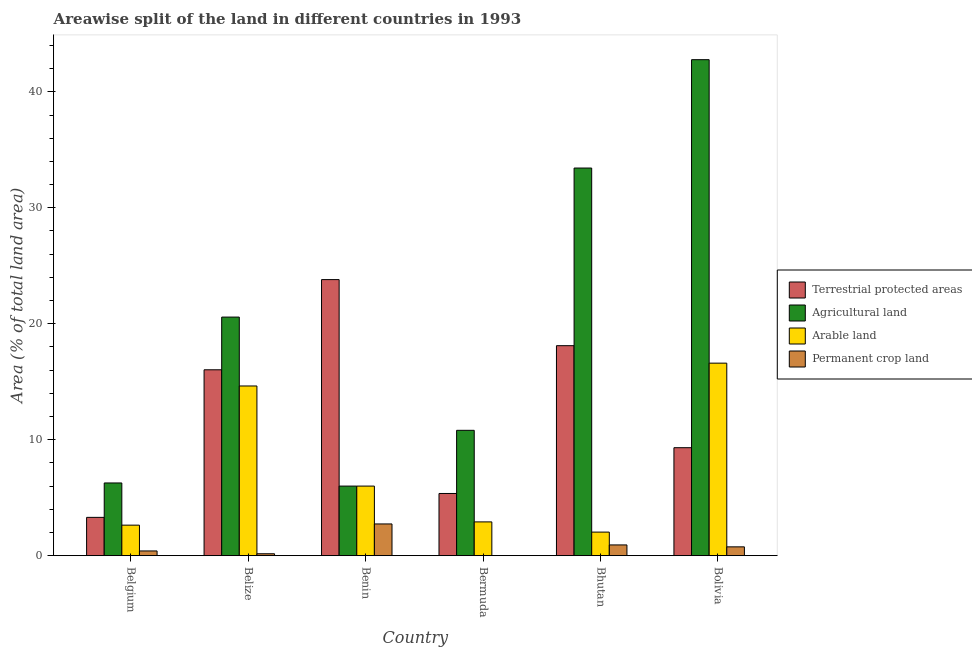Are the number of bars per tick equal to the number of legend labels?
Offer a very short reply. Yes. How many bars are there on the 3rd tick from the left?
Keep it short and to the point. 4. What is the label of the 2nd group of bars from the left?
Provide a succinct answer. Belize. In how many cases, is the number of bars for a given country not equal to the number of legend labels?
Offer a very short reply. 0. What is the percentage of land under terrestrial protection in Bhutan?
Offer a very short reply. 18.11. Across all countries, what is the maximum percentage of area under arable land?
Offer a terse response. 16.6. Across all countries, what is the minimum percentage of land under terrestrial protection?
Your answer should be compact. 3.3. In which country was the percentage of land under terrestrial protection maximum?
Your answer should be compact. Benin. In which country was the percentage of area under arable land minimum?
Your response must be concise. Bhutan. What is the total percentage of area under permanent crop land in the graph?
Offer a very short reply. 4.99. What is the difference between the percentage of area under arable land in Bhutan and that in Bolivia?
Provide a succinct answer. -14.57. What is the difference between the percentage of area under agricultural land in Benin and the percentage of area under permanent crop land in Belize?
Make the answer very short. 5.84. What is the average percentage of area under agricultural land per country?
Your answer should be compact. 19.98. What is the difference between the percentage of area under permanent crop land and percentage of area under arable land in Bermuda?
Your answer should be compact. -2.91. What is the ratio of the percentage of land under terrestrial protection in Belize to that in Benin?
Provide a short and direct response. 0.67. Is the difference between the percentage of land under terrestrial protection in Belize and Bolivia greater than the difference between the percentage of area under permanent crop land in Belize and Bolivia?
Ensure brevity in your answer.  Yes. What is the difference between the highest and the second highest percentage of area under agricultural land?
Your answer should be very brief. 9.35. What is the difference between the highest and the lowest percentage of area under arable land?
Keep it short and to the point. 14.57. In how many countries, is the percentage of area under permanent crop land greater than the average percentage of area under permanent crop land taken over all countries?
Your answer should be very brief. 2. Is it the case that in every country, the sum of the percentage of area under permanent crop land and percentage of area under arable land is greater than the sum of percentage of area under agricultural land and percentage of land under terrestrial protection?
Your answer should be compact. Yes. What does the 4th bar from the left in Belize represents?
Give a very brief answer. Permanent crop land. What does the 4th bar from the right in Bhutan represents?
Provide a succinct answer. Terrestrial protected areas. Are all the bars in the graph horizontal?
Your answer should be very brief. No. How many countries are there in the graph?
Provide a short and direct response. 6. Are the values on the major ticks of Y-axis written in scientific E-notation?
Offer a very short reply. No. Does the graph contain any zero values?
Make the answer very short. No. Does the graph contain grids?
Ensure brevity in your answer.  No. How many legend labels are there?
Provide a succinct answer. 4. What is the title of the graph?
Your answer should be very brief. Areawise split of the land in different countries in 1993. Does "PFC gas" appear as one of the legend labels in the graph?
Offer a very short reply. No. What is the label or title of the X-axis?
Offer a terse response. Country. What is the label or title of the Y-axis?
Your response must be concise. Area (% of total land area). What is the Area (% of total land area) in Terrestrial protected areas in Belgium?
Keep it short and to the point. 3.3. What is the Area (% of total land area) in Agricultural land in Belgium?
Your answer should be very brief. 6.27. What is the Area (% of total land area) in Arable land in Belgium?
Your answer should be very brief. 2.63. What is the Area (% of total land area) in Permanent crop land in Belgium?
Ensure brevity in your answer.  0.41. What is the Area (% of total land area) of Terrestrial protected areas in Belize?
Offer a very short reply. 16.03. What is the Area (% of total land area) of Agricultural land in Belize?
Your answer should be very brief. 20.57. What is the Area (% of total land area) of Arable land in Belize?
Offer a terse response. 14.63. What is the Area (% of total land area) of Permanent crop land in Belize?
Ensure brevity in your answer.  0.16. What is the Area (% of total land area) of Terrestrial protected areas in Benin?
Your response must be concise. 23.81. What is the Area (% of total land area) of Agricultural land in Benin?
Your answer should be compact. 6. What is the Area (% of total land area) of Arable land in Benin?
Provide a succinct answer. 6. What is the Area (% of total land area) of Permanent crop land in Benin?
Offer a terse response. 2.73. What is the Area (% of total land area) of Terrestrial protected areas in Bermuda?
Keep it short and to the point. 5.36. What is the Area (% of total land area) of Agricultural land in Bermuda?
Your answer should be very brief. 10.81. What is the Area (% of total land area) of Arable land in Bermuda?
Your response must be concise. 2.91. What is the Area (% of total land area) in Permanent crop land in Bermuda?
Offer a terse response. 0. What is the Area (% of total land area) in Terrestrial protected areas in Bhutan?
Offer a terse response. 18.11. What is the Area (% of total land area) in Agricultural land in Bhutan?
Give a very brief answer. 33.43. What is the Area (% of total land area) of Arable land in Bhutan?
Your response must be concise. 2.03. What is the Area (% of total land area) of Permanent crop land in Bhutan?
Provide a succinct answer. 0.93. What is the Area (% of total land area) of Terrestrial protected areas in Bolivia?
Ensure brevity in your answer.  9.31. What is the Area (% of total land area) of Agricultural land in Bolivia?
Provide a succinct answer. 42.77. What is the Area (% of total land area) in Arable land in Bolivia?
Offer a terse response. 16.6. What is the Area (% of total land area) in Permanent crop land in Bolivia?
Provide a short and direct response. 0.76. Across all countries, what is the maximum Area (% of total land area) of Terrestrial protected areas?
Your answer should be very brief. 23.81. Across all countries, what is the maximum Area (% of total land area) of Agricultural land?
Provide a short and direct response. 42.77. Across all countries, what is the maximum Area (% of total land area) in Arable land?
Your answer should be very brief. 16.6. Across all countries, what is the maximum Area (% of total land area) in Permanent crop land?
Offer a terse response. 2.73. Across all countries, what is the minimum Area (% of total land area) of Terrestrial protected areas?
Your answer should be compact. 3.3. Across all countries, what is the minimum Area (% of total land area) in Agricultural land?
Your answer should be compact. 6. Across all countries, what is the minimum Area (% of total land area) in Arable land?
Provide a succinct answer. 2.03. Across all countries, what is the minimum Area (% of total land area) in Permanent crop land?
Provide a short and direct response. 0. What is the total Area (% of total land area) of Terrestrial protected areas in the graph?
Your answer should be compact. 75.92. What is the total Area (% of total land area) of Agricultural land in the graph?
Offer a very short reply. 119.85. What is the total Area (% of total land area) of Arable land in the graph?
Offer a very short reply. 44.81. What is the total Area (% of total land area) of Permanent crop land in the graph?
Your response must be concise. 4.99. What is the difference between the Area (% of total land area) in Terrestrial protected areas in Belgium and that in Belize?
Offer a terse response. -12.73. What is the difference between the Area (% of total land area) of Agricultural land in Belgium and that in Belize?
Provide a short and direct response. -14.31. What is the difference between the Area (% of total land area) of Arable land in Belgium and that in Belize?
Offer a terse response. -12. What is the difference between the Area (% of total land area) in Permanent crop land in Belgium and that in Belize?
Provide a succinct answer. 0.24. What is the difference between the Area (% of total land area) in Terrestrial protected areas in Belgium and that in Benin?
Keep it short and to the point. -20.51. What is the difference between the Area (% of total land area) of Agricultural land in Belgium and that in Benin?
Ensure brevity in your answer.  0.27. What is the difference between the Area (% of total land area) of Arable land in Belgium and that in Benin?
Offer a very short reply. -3.37. What is the difference between the Area (% of total land area) in Permanent crop land in Belgium and that in Benin?
Provide a succinct answer. -2.33. What is the difference between the Area (% of total land area) in Terrestrial protected areas in Belgium and that in Bermuda?
Provide a succinct answer. -2.06. What is the difference between the Area (% of total land area) of Agricultural land in Belgium and that in Bermuda?
Give a very brief answer. -4.54. What is the difference between the Area (% of total land area) in Arable land in Belgium and that in Bermuda?
Provide a short and direct response. -0.28. What is the difference between the Area (% of total land area) in Permanent crop land in Belgium and that in Bermuda?
Offer a terse response. 0.4. What is the difference between the Area (% of total land area) in Terrestrial protected areas in Belgium and that in Bhutan?
Provide a succinct answer. -14.81. What is the difference between the Area (% of total land area) of Agricultural land in Belgium and that in Bhutan?
Offer a very short reply. -27.16. What is the difference between the Area (% of total land area) in Arable land in Belgium and that in Bhutan?
Provide a short and direct response. 0.6. What is the difference between the Area (% of total land area) of Permanent crop land in Belgium and that in Bhutan?
Provide a succinct answer. -0.52. What is the difference between the Area (% of total land area) of Terrestrial protected areas in Belgium and that in Bolivia?
Your answer should be very brief. -6.01. What is the difference between the Area (% of total land area) of Agricultural land in Belgium and that in Bolivia?
Make the answer very short. -36.5. What is the difference between the Area (% of total land area) of Arable land in Belgium and that in Bolivia?
Give a very brief answer. -13.97. What is the difference between the Area (% of total land area) in Permanent crop land in Belgium and that in Bolivia?
Provide a short and direct response. -0.35. What is the difference between the Area (% of total land area) of Terrestrial protected areas in Belize and that in Benin?
Offer a very short reply. -7.78. What is the difference between the Area (% of total land area) in Agricultural land in Belize and that in Benin?
Provide a short and direct response. 14.57. What is the difference between the Area (% of total land area) of Arable land in Belize and that in Benin?
Offer a very short reply. 8.63. What is the difference between the Area (% of total land area) in Permanent crop land in Belize and that in Benin?
Your answer should be compact. -2.57. What is the difference between the Area (% of total land area) of Terrestrial protected areas in Belize and that in Bermuda?
Your answer should be very brief. 10.67. What is the difference between the Area (% of total land area) in Agricultural land in Belize and that in Bermuda?
Make the answer very short. 9.77. What is the difference between the Area (% of total land area) in Arable land in Belize and that in Bermuda?
Your answer should be compact. 11.72. What is the difference between the Area (% of total land area) in Permanent crop land in Belize and that in Bermuda?
Keep it short and to the point. 0.16. What is the difference between the Area (% of total land area) of Terrestrial protected areas in Belize and that in Bhutan?
Make the answer very short. -2.08. What is the difference between the Area (% of total land area) in Agricultural land in Belize and that in Bhutan?
Ensure brevity in your answer.  -12.85. What is the difference between the Area (% of total land area) of Arable land in Belize and that in Bhutan?
Ensure brevity in your answer.  12.6. What is the difference between the Area (% of total land area) of Permanent crop land in Belize and that in Bhutan?
Give a very brief answer. -0.76. What is the difference between the Area (% of total land area) of Terrestrial protected areas in Belize and that in Bolivia?
Your response must be concise. 6.72. What is the difference between the Area (% of total land area) of Agricultural land in Belize and that in Bolivia?
Provide a short and direct response. -22.2. What is the difference between the Area (% of total land area) of Arable land in Belize and that in Bolivia?
Offer a very short reply. -1.97. What is the difference between the Area (% of total land area) in Permanent crop land in Belize and that in Bolivia?
Provide a succinct answer. -0.59. What is the difference between the Area (% of total land area) in Terrestrial protected areas in Benin and that in Bermuda?
Your answer should be compact. 18.45. What is the difference between the Area (% of total land area) in Agricultural land in Benin and that in Bermuda?
Ensure brevity in your answer.  -4.81. What is the difference between the Area (% of total land area) of Arable land in Benin and that in Bermuda?
Provide a short and direct response. 3.09. What is the difference between the Area (% of total land area) of Permanent crop land in Benin and that in Bermuda?
Your response must be concise. 2.73. What is the difference between the Area (% of total land area) in Terrestrial protected areas in Benin and that in Bhutan?
Make the answer very short. 5.7. What is the difference between the Area (% of total land area) of Agricultural land in Benin and that in Bhutan?
Provide a succinct answer. -27.43. What is the difference between the Area (% of total land area) in Arable land in Benin and that in Bhutan?
Offer a terse response. 3.97. What is the difference between the Area (% of total land area) in Permanent crop land in Benin and that in Bhutan?
Offer a terse response. 1.81. What is the difference between the Area (% of total land area) in Terrestrial protected areas in Benin and that in Bolivia?
Provide a short and direct response. 14.5. What is the difference between the Area (% of total land area) in Agricultural land in Benin and that in Bolivia?
Your response must be concise. -36.77. What is the difference between the Area (% of total land area) in Arable land in Benin and that in Bolivia?
Offer a terse response. -10.6. What is the difference between the Area (% of total land area) of Permanent crop land in Benin and that in Bolivia?
Offer a very short reply. 1.98. What is the difference between the Area (% of total land area) of Terrestrial protected areas in Bermuda and that in Bhutan?
Your answer should be compact. -12.75. What is the difference between the Area (% of total land area) of Agricultural land in Bermuda and that in Bhutan?
Your response must be concise. -22.62. What is the difference between the Area (% of total land area) in Arable land in Bermuda and that in Bhutan?
Provide a short and direct response. 0.88. What is the difference between the Area (% of total land area) of Permanent crop land in Bermuda and that in Bhutan?
Keep it short and to the point. -0.92. What is the difference between the Area (% of total land area) in Terrestrial protected areas in Bermuda and that in Bolivia?
Provide a short and direct response. -3.95. What is the difference between the Area (% of total land area) of Agricultural land in Bermuda and that in Bolivia?
Ensure brevity in your answer.  -31.97. What is the difference between the Area (% of total land area) in Arable land in Bermuda and that in Bolivia?
Offer a terse response. -13.69. What is the difference between the Area (% of total land area) in Permanent crop land in Bermuda and that in Bolivia?
Provide a succinct answer. -0.76. What is the difference between the Area (% of total land area) in Terrestrial protected areas in Bhutan and that in Bolivia?
Give a very brief answer. 8.8. What is the difference between the Area (% of total land area) of Agricultural land in Bhutan and that in Bolivia?
Your response must be concise. -9.35. What is the difference between the Area (% of total land area) in Arable land in Bhutan and that in Bolivia?
Offer a very short reply. -14.57. What is the difference between the Area (% of total land area) in Permanent crop land in Bhutan and that in Bolivia?
Offer a terse response. 0.17. What is the difference between the Area (% of total land area) in Terrestrial protected areas in Belgium and the Area (% of total land area) in Agricultural land in Belize?
Your response must be concise. -17.27. What is the difference between the Area (% of total land area) of Terrestrial protected areas in Belgium and the Area (% of total land area) of Arable land in Belize?
Ensure brevity in your answer.  -11.33. What is the difference between the Area (% of total land area) in Terrestrial protected areas in Belgium and the Area (% of total land area) in Permanent crop land in Belize?
Your response must be concise. 3.14. What is the difference between the Area (% of total land area) in Agricultural land in Belgium and the Area (% of total land area) in Arable land in Belize?
Give a very brief answer. -8.36. What is the difference between the Area (% of total land area) of Agricultural land in Belgium and the Area (% of total land area) of Permanent crop land in Belize?
Give a very brief answer. 6.1. What is the difference between the Area (% of total land area) in Arable land in Belgium and the Area (% of total land area) in Permanent crop land in Belize?
Ensure brevity in your answer.  2.47. What is the difference between the Area (% of total land area) in Terrestrial protected areas in Belgium and the Area (% of total land area) in Agricultural land in Benin?
Offer a terse response. -2.7. What is the difference between the Area (% of total land area) in Terrestrial protected areas in Belgium and the Area (% of total land area) in Arable land in Benin?
Make the answer very short. -2.7. What is the difference between the Area (% of total land area) of Terrestrial protected areas in Belgium and the Area (% of total land area) of Permanent crop land in Benin?
Offer a very short reply. 0.57. What is the difference between the Area (% of total land area) in Agricultural land in Belgium and the Area (% of total land area) in Arable land in Benin?
Provide a short and direct response. 0.27. What is the difference between the Area (% of total land area) in Agricultural land in Belgium and the Area (% of total land area) in Permanent crop land in Benin?
Offer a terse response. 3.53. What is the difference between the Area (% of total land area) of Arable land in Belgium and the Area (% of total land area) of Permanent crop land in Benin?
Your response must be concise. -0.1. What is the difference between the Area (% of total land area) in Terrestrial protected areas in Belgium and the Area (% of total land area) in Agricultural land in Bermuda?
Your answer should be compact. -7.51. What is the difference between the Area (% of total land area) in Terrestrial protected areas in Belgium and the Area (% of total land area) in Arable land in Bermuda?
Make the answer very short. 0.39. What is the difference between the Area (% of total land area) in Terrestrial protected areas in Belgium and the Area (% of total land area) in Permanent crop land in Bermuda?
Give a very brief answer. 3.3. What is the difference between the Area (% of total land area) of Agricultural land in Belgium and the Area (% of total land area) of Arable land in Bermuda?
Offer a terse response. 3.36. What is the difference between the Area (% of total land area) of Agricultural land in Belgium and the Area (% of total land area) of Permanent crop land in Bermuda?
Your answer should be compact. 6.27. What is the difference between the Area (% of total land area) of Arable land in Belgium and the Area (% of total land area) of Permanent crop land in Bermuda?
Keep it short and to the point. 2.63. What is the difference between the Area (% of total land area) in Terrestrial protected areas in Belgium and the Area (% of total land area) in Agricultural land in Bhutan?
Your response must be concise. -30.13. What is the difference between the Area (% of total land area) of Terrestrial protected areas in Belgium and the Area (% of total land area) of Arable land in Bhutan?
Your answer should be compact. 1.27. What is the difference between the Area (% of total land area) in Terrestrial protected areas in Belgium and the Area (% of total land area) in Permanent crop land in Bhutan?
Your answer should be compact. 2.38. What is the difference between the Area (% of total land area) in Agricultural land in Belgium and the Area (% of total land area) in Arable land in Bhutan?
Provide a succinct answer. 4.24. What is the difference between the Area (% of total land area) of Agricultural land in Belgium and the Area (% of total land area) of Permanent crop land in Bhutan?
Make the answer very short. 5.34. What is the difference between the Area (% of total land area) in Arable land in Belgium and the Area (% of total land area) in Permanent crop land in Bhutan?
Give a very brief answer. 1.7. What is the difference between the Area (% of total land area) of Terrestrial protected areas in Belgium and the Area (% of total land area) of Agricultural land in Bolivia?
Ensure brevity in your answer.  -39.47. What is the difference between the Area (% of total land area) of Terrestrial protected areas in Belgium and the Area (% of total land area) of Arable land in Bolivia?
Offer a terse response. -13.3. What is the difference between the Area (% of total land area) in Terrestrial protected areas in Belgium and the Area (% of total land area) in Permanent crop land in Bolivia?
Your answer should be compact. 2.54. What is the difference between the Area (% of total land area) in Agricultural land in Belgium and the Area (% of total land area) in Arable land in Bolivia?
Your answer should be very brief. -10.33. What is the difference between the Area (% of total land area) in Agricultural land in Belgium and the Area (% of total land area) in Permanent crop land in Bolivia?
Your answer should be very brief. 5.51. What is the difference between the Area (% of total land area) in Arable land in Belgium and the Area (% of total land area) in Permanent crop land in Bolivia?
Your answer should be compact. 1.87. What is the difference between the Area (% of total land area) of Terrestrial protected areas in Belize and the Area (% of total land area) of Agricultural land in Benin?
Provide a succinct answer. 10.03. What is the difference between the Area (% of total land area) of Terrestrial protected areas in Belize and the Area (% of total land area) of Arable land in Benin?
Offer a terse response. 10.03. What is the difference between the Area (% of total land area) of Terrestrial protected areas in Belize and the Area (% of total land area) of Permanent crop land in Benin?
Offer a terse response. 13.3. What is the difference between the Area (% of total land area) of Agricultural land in Belize and the Area (% of total land area) of Arable land in Benin?
Your response must be concise. 14.57. What is the difference between the Area (% of total land area) of Agricultural land in Belize and the Area (% of total land area) of Permanent crop land in Benin?
Provide a short and direct response. 17.84. What is the difference between the Area (% of total land area) in Arable land in Belize and the Area (% of total land area) in Permanent crop land in Benin?
Your answer should be very brief. 11.9. What is the difference between the Area (% of total land area) in Terrestrial protected areas in Belize and the Area (% of total land area) in Agricultural land in Bermuda?
Make the answer very short. 5.22. What is the difference between the Area (% of total land area) in Terrestrial protected areas in Belize and the Area (% of total land area) in Arable land in Bermuda?
Give a very brief answer. 13.12. What is the difference between the Area (% of total land area) in Terrestrial protected areas in Belize and the Area (% of total land area) in Permanent crop land in Bermuda?
Provide a succinct answer. 16.03. What is the difference between the Area (% of total land area) of Agricultural land in Belize and the Area (% of total land area) of Arable land in Bermuda?
Offer a terse response. 17.66. What is the difference between the Area (% of total land area) of Agricultural land in Belize and the Area (% of total land area) of Permanent crop land in Bermuda?
Your answer should be compact. 20.57. What is the difference between the Area (% of total land area) of Arable land in Belize and the Area (% of total land area) of Permanent crop land in Bermuda?
Give a very brief answer. 14.63. What is the difference between the Area (% of total land area) in Terrestrial protected areas in Belize and the Area (% of total land area) in Agricultural land in Bhutan?
Offer a very short reply. -17.4. What is the difference between the Area (% of total land area) of Terrestrial protected areas in Belize and the Area (% of total land area) of Arable land in Bhutan?
Your answer should be compact. 14. What is the difference between the Area (% of total land area) of Terrestrial protected areas in Belize and the Area (% of total land area) of Permanent crop land in Bhutan?
Offer a terse response. 15.1. What is the difference between the Area (% of total land area) in Agricultural land in Belize and the Area (% of total land area) in Arable land in Bhutan?
Ensure brevity in your answer.  18.54. What is the difference between the Area (% of total land area) of Agricultural land in Belize and the Area (% of total land area) of Permanent crop land in Bhutan?
Your response must be concise. 19.65. What is the difference between the Area (% of total land area) of Arable land in Belize and the Area (% of total land area) of Permanent crop land in Bhutan?
Give a very brief answer. 13.71. What is the difference between the Area (% of total land area) in Terrestrial protected areas in Belize and the Area (% of total land area) in Agricultural land in Bolivia?
Offer a terse response. -26.74. What is the difference between the Area (% of total land area) of Terrestrial protected areas in Belize and the Area (% of total land area) of Arable land in Bolivia?
Your response must be concise. -0.57. What is the difference between the Area (% of total land area) in Terrestrial protected areas in Belize and the Area (% of total land area) in Permanent crop land in Bolivia?
Offer a very short reply. 15.27. What is the difference between the Area (% of total land area) of Agricultural land in Belize and the Area (% of total land area) of Arable land in Bolivia?
Provide a short and direct response. 3.97. What is the difference between the Area (% of total land area) of Agricultural land in Belize and the Area (% of total land area) of Permanent crop land in Bolivia?
Make the answer very short. 19.82. What is the difference between the Area (% of total land area) in Arable land in Belize and the Area (% of total land area) in Permanent crop land in Bolivia?
Make the answer very short. 13.87. What is the difference between the Area (% of total land area) in Terrestrial protected areas in Benin and the Area (% of total land area) in Agricultural land in Bermuda?
Ensure brevity in your answer.  13. What is the difference between the Area (% of total land area) in Terrestrial protected areas in Benin and the Area (% of total land area) in Arable land in Bermuda?
Offer a terse response. 20.9. What is the difference between the Area (% of total land area) in Terrestrial protected areas in Benin and the Area (% of total land area) in Permanent crop land in Bermuda?
Provide a short and direct response. 23.81. What is the difference between the Area (% of total land area) in Agricultural land in Benin and the Area (% of total land area) in Arable land in Bermuda?
Your answer should be very brief. 3.09. What is the difference between the Area (% of total land area) of Agricultural land in Benin and the Area (% of total land area) of Permanent crop land in Bermuda?
Keep it short and to the point. 6. What is the difference between the Area (% of total land area) in Arable land in Benin and the Area (% of total land area) in Permanent crop land in Bermuda?
Give a very brief answer. 6. What is the difference between the Area (% of total land area) in Terrestrial protected areas in Benin and the Area (% of total land area) in Agricultural land in Bhutan?
Your response must be concise. -9.62. What is the difference between the Area (% of total land area) in Terrestrial protected areas in Benin and the Area (% of total land area) in Arable land in Bhutan?
Give a very brief answer. 21.78. What is the difference between the Area (% of total land area) of Terrestrial protected areas in Benin and the Area (% of total land area) of Permanent crop land in Bhutan?
Your answer should be very brief. 22.88. What is the difference between the Area (% of total land area) in Agricultural land in Benin and the Area (% of total land area) in Arable land in Bhutan?
Your answer should be very brief. 3.97. What is the difference between the Area (% of total land area) of Agricultural land in Benin and the Area (% of total land area) of Permanent crop land in Bhutan?
Your answer should be compact. 5.07. What is the difference between the Area (% of total land area) of Arable land in Benin and the Area (% of total land area) of Permanent crop land in Bhutan?
Your response must be concise. 5.07. What is the difference between the Area (% of total land area) of Terrestrial protected areas in Benin and the Area (% of total land area) of Agricultural land in Bolivia?
Provide a succinct answer. -18.97. What is the difference between the Area (% of total land area) in Terrestrial protected areas in Benin and the Area (% of total land area) in Arable land in Bolivia?
Make the answer very short. 7.21. What is the difference between the Area (% of total land area) in Terrestrial protected areas in Benin and the Area (% of total land area) in Permanent crop land in Bolivia?
Offer a very short reply. 23.05. What is the difference between the Area (% of total land area) of Agricultural land in Benin and the Area (% of total land area) of Arable land in Bolivia?
Provide a succinct answer. -10.6. What is the difference between the Area (% of total land area) in Agricultural land in Benin and the Area (% of total land area) in Permanent crop land in Bolivia?
Give a very brief answer. 5.24. What is the difference between the Area (% of total land area) of Arable land in Benin and the Area (% of total land area) of Permanent crop land in Bolivia?
Ensure brevity in your answer.  5.24. What is the difference between the Area (% of total land area) of Terrestrial protected areas in Bermuda and the Area (% of total land area) of Agricultural land in Bhutan?
Provide a short and direct response. -28.07. What is the difference between the Area (% of total land area) of Terrestrial protected areas in Bermuda and the Area (% of total land area) of Arable land in Bhutan?
Your answer should be very brief. 3.33. What is the difference between the Area (% of total land area) in Terrestrial protected areas in Bermuda and the Area (% of total land area) in Permanent crop land in Bhutan?
Keep it short and to the point. 4.44. What is the difference between the Area (% of total land area) in Agricultural land in Bermuda and the Area (% of total land area) in Arable land in Bhutan?
Give a very brief answer. 8.78. What is the difference between the Area (% of total land area) in Agricultural land in Bermuda and the Area (% of total land area) in Permanent crop land in Bhutan?
Give a very brief answer. 9.88. What is the difference between the Area (% of total land area) in Arable land in Bermuda and the Area (% of total land area) in Permanent crop land in Bhutan?
Give a very brief answer. 1.99. What is the difference between the Area (% of total land area) of Terrestrial protected areas in Bermuda and the Area (% of total land area) of Agricultural land in Bolivia?
Offer a very short reply. -37.41. What is the difference between the Area (% of total land area) of Terrestrial protected areas in Bermuda and the Area (% of total land area) of Arable land in Bolivia?
Make the answer very short. -11.24. What is the difference between the Area (% of total land area) in Terrestrial protected areas in Bermuda and the Area (% of total land area) in Permanent crop land in Bolivia?
Ensure brevity in your answer.  4.6. What is the difference between the Area (% of total land area) in Agricultural land in Bermuda and the Area (% of total land area) in Arable land in Bolivia?
Give a very brief answer. -5.79. What is the difference between the Area (% of total land area) of Agricultural land in Bermuda and the Area (% of total land area) of Permanent crop land in Bolivia?
Your answer should be very brief. 10.05. What is the difference between the Area (% of total land area) in Arable land in Bermuda and the Area (% of total land area) in Permanent crop land in Bolivia?
Your response must be concise. 2.15. What is the difference between the Area (% of total land area) in Terrestrial protected areas in Bhutan and the Area (% of total land area) in Agricultural land in Bolivia?
Provide a short and direct response. -24.66. What is the difference between the Area (% of total land area) of Terrestrial protected areas in Bhutan and the Area (% of total land area) of Arable land in Bolivia?
Offer a terse response. 1.51. What is the difference between the Area (% of total land area) of Terrestrial protected areas in Bhutan and the Area (% of total land area) of Permanent crop land in Bolivia?
Your response must be concise. 17.35. What is the difference between the Area (% of total land area) in Agricultural land in Bhutan and the Area (% of total land area) in Arable land in Bolivia?
Keep it short and to the point. 16.83. What is the difference between the Area (% of total land area) of Agricultural land in Bhutan and the Area (% of total land area) of Permanent crop land in Bolivia?
Offer a terse response. 32.67. What is the difference between the Area (% of total land area) of Arable land in Bhutan and the Area (% of total land area) of Permanent crop land in Bolivia?
Your response must be concise. 1.27. What is the average Area (% of total land area) in Terrestrial protected areas per country?
Make the answer very short. 12.65. What is the average Area (% of total land area) of Agricultural land per country?
Your response must be concise. 19.98. What is the average Area (% of total land area) in Arable land per country?
Keep it short and to the point. 7.47. What is the average Area (% of total land area) of Permanent crop land per country?
Offer a very short reply. 0.83. What is the difference between the Area (% of total land area) in Terrestrial protected areas and Area (% of total land area) in Agricultural land in Belgium?
Your answer should be compact. -2.97. What is the difference between the Area (% of total land area) in Terrestrial protected areas and Area (% of total land area) in Arable land in Belgium?
Keep it short and to the point. 0.67. What is the difference between the Area (% of total land area) in Terrestrial protected areas and Area (% of total land area) in Permanent crop land in Belgium?
Give a very brief answer. 2.89. What is the difference between the Area (% of total land area) in Agricultural land and Area (% of total land area) in Arable land in Belgium?
Make the answer very short. 3.64. What is the difference between the Area (% of total land area) in Agricultural land and Area (% of total land area) in Permanent crop land in Belgium?
Offer a terse response. 5.86. What is the difference between the Area (% of total land area) in Arable land and Area (% of total land area) in Permanent crop land in Belgium?
Your answer should be very brief. 2.22. What is the difference between the Area (% of total land area) of Terrestrial protected areas and Area (% of total land area) of Agricultural land in Belize?
Offer a very short reply. -4.55. What is the difference between the Area (% of total land area) in Terrestrial protected areas and Area (% of total land area) in Arable land in Belize?
Your answer should be compact. 1.4. What is the difference between the Area (% of total land area) of Terrestrial protected areas and Area (% of total land area) of Permanent crop land in Belize?
Offer a very short reply. 15.87. What is the difference between the Area (% of total land area) of Agricultural land and Area (% of total land area) of Arable land in Belize?
Offer a terse response. 5.94. What is the difference between the Area (% of total land area) in Agricultural land and Area (% of total land area) in Permanent crop land in Belize?
Keep it short and to the point. 20.41. What is the difference between the Area (% of total land area) of Arable land and Area (% of total land area) of Permanent crop land in Belize?
Offer a terse response. 14.47. What is the difference between the Area (% of total land area) of Terrestrial protected areas and Area (% of total land area) of Agricultural land in Benin?
Make the answer very short. 17.81. What is the difference between the Area (% of total land area) of Terrestrial protected areas and Area (% of total land area) of Arable land in Benin?
Provide a succinct answer. 17.81. What is the difference between the Area (% of total land area) of Terrestrial protected areas and Area (% of total land area) of Permanent crop land in Benin?
Keep it short and to the point. 21.07. What is the difference between the Area (% of total land area) in Agricultural land and Area (% of total land area) in Permanent crop land in Benin?
Give a very brief answer. 3.27. What is the difference between the Area (% of total land area) in Arable land and Area (% of total land area) in Permanent crop land in Benin?
Keep it short and to the point. 3.27. What is the difference between the Area (% of total land area) of Terrestrial protected areas and Area (% of total land area) of Agricultural land in Bermuda?
Your response must be concise. -5.45. What is the difference between the Area (% of total land area) in Terrestrial protected areas and Area (% of total land area) in Arable land in Bermuda?
Provide a short and direct response. 2.45. What is the difference between the Area (% of total land area) of Terrestrial protected areas and Area (% of total land area) of Permanent crop land in Bermuda?
Offer a very short reply. 5.36. What is the difference between the Area (% of total land area) of Agricultural land and Area (% of total land area) of Arable land in Bermuda?
Provide a short and direct response. 7.9. What is the difference between the Area (% of total land area) of Agricultural land and Area (% of total land area) of Permanent crop land in Bermuda?
Your answer should be compact. 10.81. What is the difference between the Area (% of total land area) of Arable land and Area (% of total land area) of Permanent crop land in Bermuda?
Make the answer very short. 2.91. What is the difference between the Area (% of total land area) of Terrestrial protected areas and Area (% of total land area) of Agricultural land in Bhutan?
Your response must be concise. -15.32. What is the difference between the Area (% of total land area) of Terrestrial protected areas and Area (% of total land area) of Arable land in Bhutan?
Ensure brevity in your answer.  16.08. What is the difference between the Area (% of total land area) of Terrestrial protected areas and Area (% of total land area) of Permanent crop land in Bhutan?
Your response must be concise. 17.18. What is the difference between the Area (% of total land area) of Agricultural land and Area (% of total land area) of Arable land in Bhutan?
Provide a short and direct response. 31.4. What is the difference between the Area (% of total land area) in Agricultural land and Area (% of total land area) in Permanent crop land in Bhutan?
Ensure brevity in your answer.  32.5. What is the difference between the Area (% of total land area) of Arable land and Area (% of total land area) of Permanent crop land in Bhutan?
Your response must be concise. 1.11. What is the difference between the Area (% of total land area) in Terrestrial protected areas and Area (% of total land area) in Agricultural land in Bolivia?
Ensure brevity in your answer.  -33.46. What is the difference between the Area (% of total land area) of Terrestrial protected areas and Area (% of total land area) of Arable land in Bolivia?
Provide a short and direct response. -7.29. What is the difference between the Area (% of total land area) in Terrestrial protected areas and Area (% of total land area) in Permanent crop land in Bolivia?
Your answer should be compact. 8.55. What is the difference between the Area (% of total land area) of Agricultural land and Area (% of total land area) of Arable land in Bolivia?
Your response must be concise. 26.17. What is the difference between the Area (% of total land area) of Agricultural land and Area (% of total land area) of Permanent crop land in Bolivia?
Your answer should be compact. 42.01. What is the difference between the Area (% of total land area) of Arable land and Area (% of total land area) of Permanent crop land in Bolivia?
Keep it short and to the point. 15.84. What is the ratio of the Area (% of total land area) of Terrestrial protected areas in Belgium to that in Belize?
Your answer should be very brief. 0.21. What is the ratio of the Area (% of total land area) in Agricultural land in Belgium to that in Belize?
Your answer should be very brief. 0.3. What is the ratio of the Area (% of total land area) in Arable land in Belgium to that in Belize?
Offer a terse response. 0.18. What is the ratio of the Area (% of total land area) of Permanent crop land in Belgium to that in Belize?
Make the answer very short. 2.47. What is the ratio of the Area (% of total land area) of Terrestrial protected areas in Belgium to that in Benin?
Keep it short and to the point. 0.14. What is the ratio of the Area (% of total land area) of Agricultural land in Belgium to that in Benin?
Your response must be concise. 1.04. What is the ratio of the Area (% of total land area) of Arable land in Belgium to that in Benin?
Provide a succinct answer. 0.44. What is the ratio of the Area (% of total land area) in Permanent crop land in Belgium to that in Benin?
Make the answer very short. 0.15. What is the ratio of the Area (% of total land area) in Terrestrial protected areas in Belgium to that in Bermuda?
Give a very brief answer. 0.62. What is the ratio of the Area (% of total land area) of Agricultural land in Belgium to that in Bermuda?
Ensure brevity in your answer.  0.58. What is the ratio of the Area (% of total land area) in Arable land in Belgium to that in Bermuda?
Offer a very short reply. 0.9. What is the ratio of the Area (% of total land area) in Permanent crop land in Belgium to that in Bermuda?
Your answer should be compact. 230.46. What is the ratio of the Area (% of total land area) in Terrestrial protected areas in Belgium to that in Bhutan?
Your response must be concise. 0.18. What is the ratio of the Area (% of total land area) of Agricultural land in Belgium to that in Bhutan?
Provide a succinct answer. 0.19. What is the ratio of the Area (% of total land area) in Arable land in Belgium to that in Bhutan?
Your response must be concise. 1.3. What is the ratio of the Area (% of total land area) of Permanent crop land in Belgium to that in Bhutan?
Provide a short and direct response. 0.44. What is the ratio of the Area (% of total land area) in Terrestrial protected areas in Belgium to that in Bolivia?
Provide a short and direct response. 0.35. What is the ratio of the Area (% of total land area) in Agricultural land in Belgium to that in Bolivia?
Your answer should be very brief. 0.15. What is the ratio of the Area (% of total land area) of Arable land in Belgium to that in Bolivia?
Keep it short and to the point. 0.16. What is the ratio of the Area (% of total land area) of Permanent crop land in Belgium to that in Bolivia?
Offer a very short reply. 0.54. What is the ratio of the Area (% of total land area) of Terrestrial protected areas in Belize to that in Benin?
Make the answer very short. 0.67. What is the ratio of the Area (% of total land area) of Agricultural land in Belize to that in Benin?
Provide a short and direct response. 3.43. What is the ratio of the Area (% of total land area) of Arable land in Belize to that in Benin?
Your answer should be very brief. 2.44. What is the ratio of the Area (% of total land area) of Permanent crop land in Belize to that in Benin?
Make the answer very short. 0.06. What is the ratio of the Area (% of total land area) in Terrestrial protected areas in Belize to that in Bermuda?
Your answer should be compact. 2.99. What is the ratio of the Area (% of total land area) in Agricultural land in Belize to that in Bermuda?
Give a very brief answer. 1.9. What is the ratio of the Area (% of total land area) of Arable land in Belize to that in Bermuda?
Offer a terse response. 5.03. What is the ratio of the Area (% of total land area) in Permanent crop land in Belize to that in Bermuda?
Provide a succinct answer. 93.12. What is the ratio of the Area (% of total land area) of Terrestrial protected areas in Belize to that in Bhutan?
Your answer should be compact. 0.89. What is the ratio of the Area (% of total land area) in Agricultural land in Belize to that in Bhutan?
Offer a terse response. 0.62. What is the ratio of the Area (% of total land area) of Arable land in Belize to that in Bhutan?
Make the answer very short. 7.21. What is the ratio of the Area (% of total land area) of Permanent crop land in Belize to that in Bhutan?
Offer a very short reply. 0.18. What is the ratio of the Area (% of total land area) of Terrestrial protected areas in Belize to that in Bolivia?
Give a very brief answer. 1.72. What is the ratio of the Area (% of total land area) of Agricultural land in Belize to that in Bolivia?
Ensure brevity in your answer.  0.48. What is the ratio of the Area (% of total land area) of Arable land in Belize to that in Bolivia?
Your response must be concise. 0.88. What is the ratio of the Area (% of total land area) in Permanent crop land in Belize to that in Bolivia?
Your response must be concise. 0.22. What is the ratio of the Area (% of total land area) in Terrestrial protected areas in Benin to that in Bermuda?
Offer a very short reply. 4.44. What is the ratio of the Area (% of total land area) of Agricultural land in Benin to that in Bermuda?
Provide a short and direct response. 0.56. What is the ratio of the Area (% of total land area) in Arable land in Benin to that in Bermuda?
Your answer should be compact. 2.06. What is the ratio of the Area (% of total land area) of Permanent crop land in Benin to that in Bermuda?
Your response must be concise. 1549.65. What is the ratio of the Area (% of total land area) of Terrestrial protected areas in Benin to that in Bhutan?
Your answer should be compact. 1.31. What is the ratio of the Area (% of total land area) of Agricultural land in Benin to that in Bhutan?
Offer a very short reply. 0.18. What is the ratio of the Area (% of total land area) in Arable land in Benin to that in Bhutan?
Provide a short and direct response. 2.95. What is the ratio of the Area (% of total land area) in Permanent crop land in Benin to that in Bhutan?
Your response must be concise. 2.95. What is the ratio of the Area (% of total land area) in Terrestrial protected areas in Benin to that in Bolivia?
Make the answer very short. 2.56. What is the ratio of the Area (% of total land area) of Agricultural land in Benin to that in Bolivia?
Offer a terse response. 0.14. What is the ratio of the Area (% of total land area) in Arable land in Benin to that in Bolivia?
Keep it short and to the point. 0.36. What is the ratio of the Area (% of total land area) of Permanent crop land in Benin to that in Bolivia?
Ensure brevity in your answer.  3.6. What is the ratio of the Area (% of total land area) in Terrestrial protected areas in Bermuda to that in Bhutan?
Provide a succinct answer. 0.3. What is the ratio of the Area (% of total land area) in Agricultural land in Bermuda to that in Bhutan?
Your answer should be compact. 0.32. What is the ratio of the Area (% of total land area) in Arable land in Bermuda to that in Bhutan?
Make the answer very short. 1.43. What is the ratio of the Area (% of total land area) in Permanent crop land in Bermuda to that in Bhutan?
Your answer should be compact. 0. What is the ratio of the Area (% of total land area) of Terrestrial protected areas in Bermuda to that in Bolivia?
Provide a succinct answer. 0.58. What is the ratio of the Area (% of total land area) of Agricultural land in Bermuda to that in Bolivia?
Give a very brief answer. 0.25. What is the ratio of the Area (% of total land area) of Arable land in Bermuda to that in Bolivia?
Offer a terse response. 0.18. What is the ratio of the Area (% of total land area) of Permanent crop land in Bermuda to that in Bolivia?
Give a very brief answer. 0. What is the ratio of the Area (% of total land area) of Terrestrial protected areas in Bhutan to that in Bolivia?
Offer a very short reply. 1.94. What is the ratio of the Area (% of total land area) of Agricultural land in Bhutan to that in Bolivia?
Provide a succinct answer. 0.78. What is the ratio of the Area (% of total land area) in Arable land in Bhutan to that in Bolivia?
Ensure brevity in your answer.  0.12. What is the ratio of the Area (% of total land area) of Permanent crop land in Bhutan to that in Bolivia?
Give a very brief answer. 1.22. What is the difference between the highest and the second highest Area (% of total land area) of Terrestrial protected areas?
Ensure brevity in your answer.  5.7. What is the difference between the highest and the second highest Area (% of total land area) of Agricultural land?
Offer a terse response. 9.35. What is the difference between the highest and the second highest Area (% of total land area) of Arable land?
Provide a succinct answer. 1.97. What is the difference between the highest and the second highest Area (% of total land area) in Permanent crop land?
Make the answer very short. 1.81. What is the difference between the highest and the lowest Area (% of total land area) of Terrestrial protected areas?
Provide a short and direct response. 20.51. What is the difference between the highest and the lowest Area (% of total land area) of Agricultural land?
Ensure brevity in your answer.  36.77. What is the difference between the highest and the lowest Area (% of total land area) in Arable land?
Offer a terse response. 14.57. What is the difference between the highest and the lowest Area (% of total land area) of Permanent crop land?
Your answer should be very brief. 2.73. 